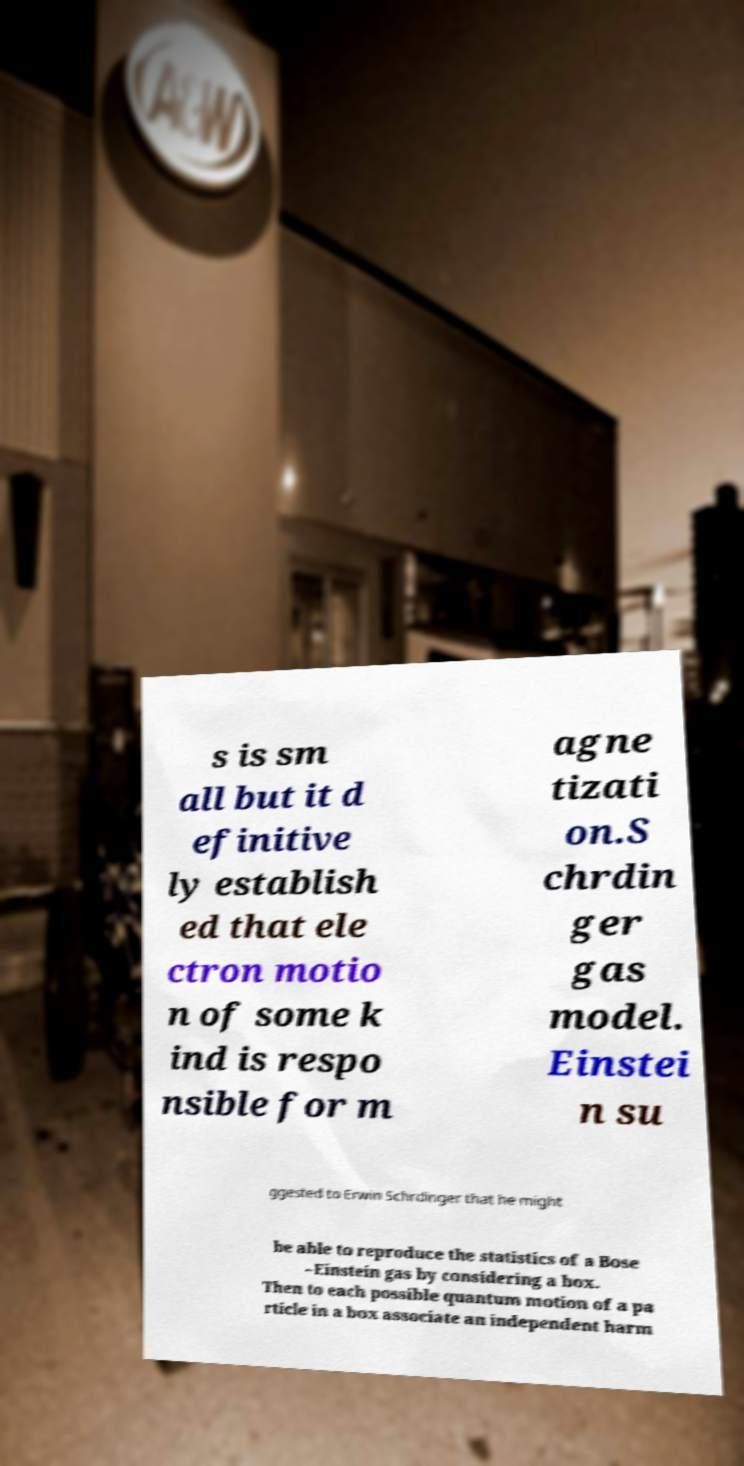Could you extract and type out the text from this image? s is sm all but it d efinitive ly establish ed that ele ctron motio n of some k ind is respo nsible for m agne tizati on.S chrdin ger gas model. Einstei n su ggested to Erwin Schrdinger that he might be able to reproduce the statistics of a Bose –Einstein gas by considering a box. Then to each possible quantum motion of a pa rticle in a box associate an independent harm 